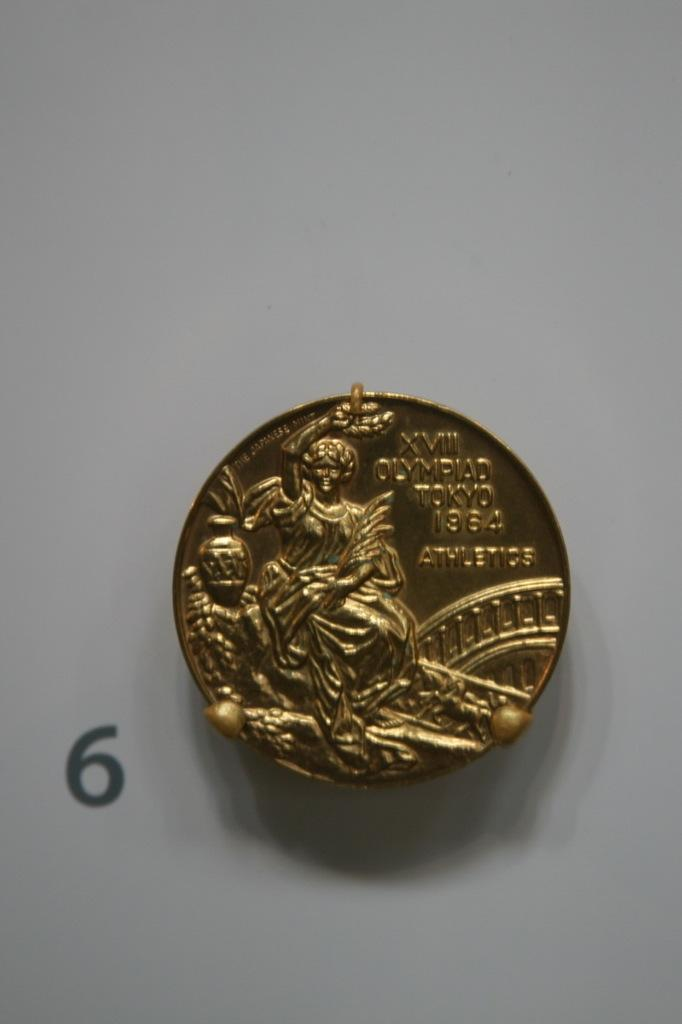<image>
Describe the image concisely. XVIII Olympiad Tokyo 1964  Athletics gold coin 